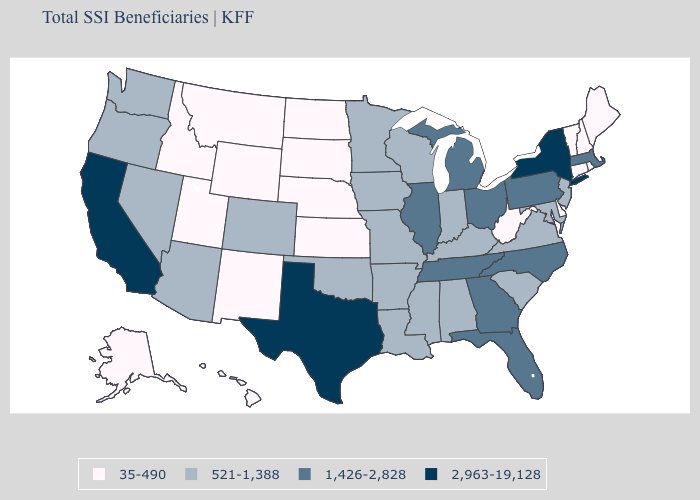What is the value of Iowa?
Give a very brief answer. 521-1,388. Which states have the lowest value in the MidWest?
Keep it brief. Kansas, Nebraska, North Dakota, South Dakota. Among the states that border Wyoming , which have the lowest value?
Quick response, please. Idaho, Montana, Nebraska, South Dakota, Utah. Name the states that have a value in the range 521-1,388?
Write a very short answer. Alabama, Arizona, Arkansas, Colorado, Indiana, Iowa, Kentucky, Louisiana, Maryland, Minnesota, Mississippi, Missouri, Nevada, New Jersey, Oklahoma, Oregon, South Carolina, Virginia, Washington, Wisconsin. Among the states that border New York , which have the lowest value?
Keep it brief. Connecticut, Vermont. Name the states that have a value in the range 1,426-2,828?
Keep it brief. Florida, Georgia, Illinois, Massachusetts, Michigan, North Carolina, Ohio, Pennsylvania, Tennessee. Does the map have missing data?
Short answer required. No. Does Rhode Island have the same value as Vermont?
Write a very short answer. Yes. Which states have the highest value in the USA?
Write a very short answer. California, New York, Texas. Does Louisiana have the lowest value in the South?
Give a very brief answer. No. Does Mississippi have the lowest value in the South?
Give a very brief answer. No. Which states hav the highest value in the MidWest?
Concise answer only. Illinois, Michigan, Ohio. Does Tennessee have a lower value than Nevada?
Give a very brief answer. No. What is the value of South Dakota?
Short answer required. 35-490. What is the value of Georgia?
Give a very brief answer. 1,426-2,828. 